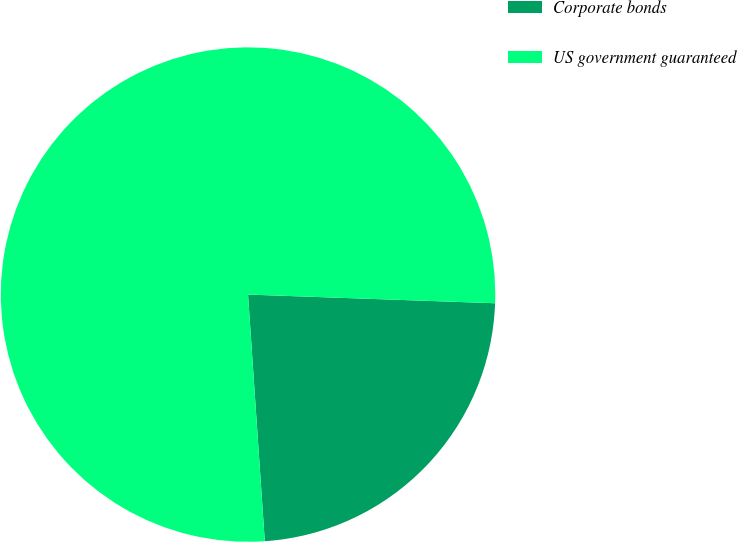Convert chart. <chart><loc_0><loc_0><loc_500><loc_500><pie_chart><fcel>Corporate bonds<fcel>US government guaranteed<nl><fcel>23.36%<fcel>76.64%<nl></chart> 